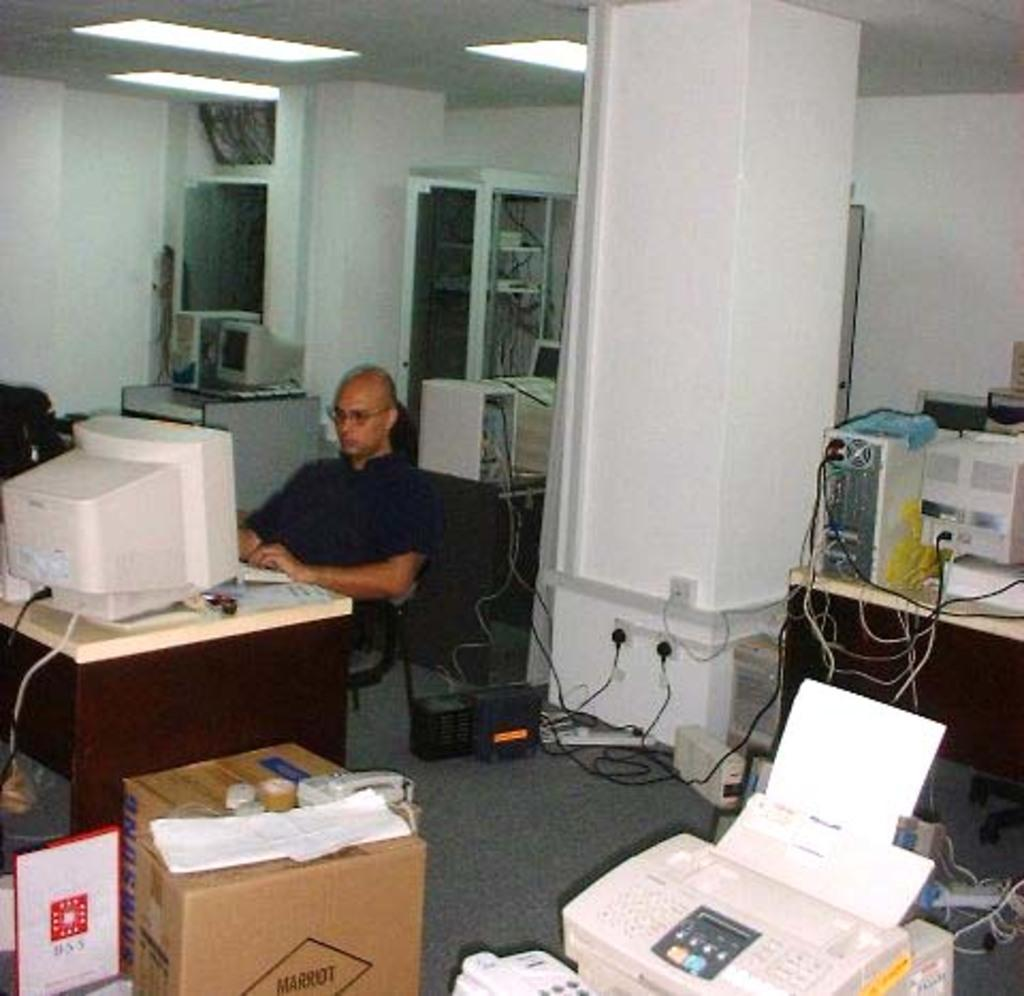What is the man in the image doing? The man is sitting on a chair in the image. What type of furniture can be seen in the image? There are tables in the image. What electronic devices are present in the image? There are monitors, CPU (central processing units), and devices in the image. What type of equipment is used to connect the devices in the image? There are cables in the image. What type of storage containers are present in the image? There are boxes in the image. What structural element is present in the image? There is a pillar in the image. What can be seen in the background of the image? There are lights and a wall in the background of the image. How many fish are swimming in the bowl on the table in the image? There is no fishbowl or fish present in the image. What type of animal can be seen grazing in the background of the image? There are no animals, including deer, present in the image. 